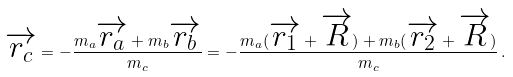Convert formula to latex. <formula><loc_0><loc_0><loc_500><loc_500>\overrightarrow { r _ { c } } = - \frac { m _ { a } \overrightarrow { r _ { a } } + m _ { b } \overrightarrow { r _ { b } } } { m _ { c } } = - \frac { m _ { a } ( \overrightarrow { r _ { 1 } } + \overrightarrow { R } ) + m _ { b } ( \overrightarrow { r _ { 2 } } + \overrightarrow { R } ) } { m _ { c } } \, .</formula> 